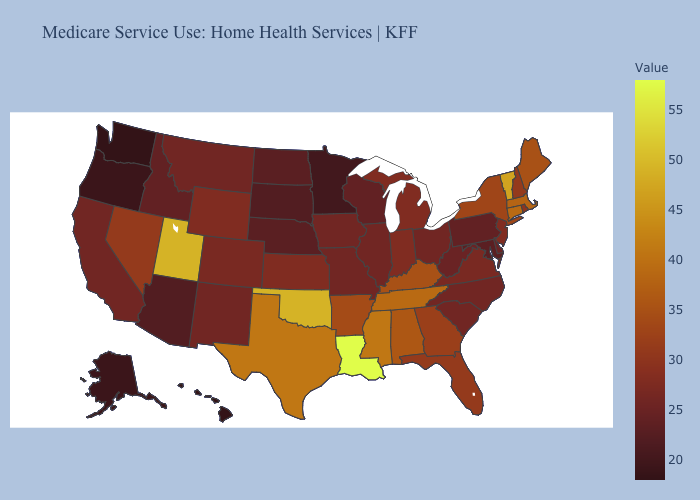Does the map have missing data?
Give a very brief answer. No. Does Louisiana have the highest value in the USA?
Short answer required. Yes. Among the states that border Washington , does Oregon have the highest value?
Be succinct. No. Which states hav the highest value in the South?
Keep it brief. Louisiana. Does Pennsylvania have the lowest value in the Northeast?
Answer briefly. Yes. 